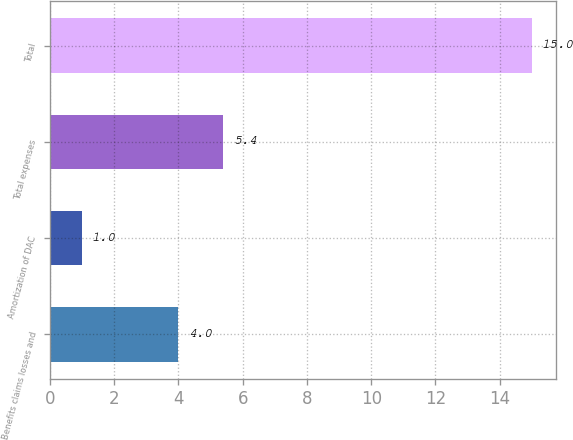<chart> <loc_0><loc_0><loc_500><loc_500><bar_chart><fcel>Benefits claims losses and<fcel>Amortization of DAC<fcel>Total expenses<fcel>Total<nl><fcel>4<fcel>1<fcel>5.4<fcel>15<nl></chart> 